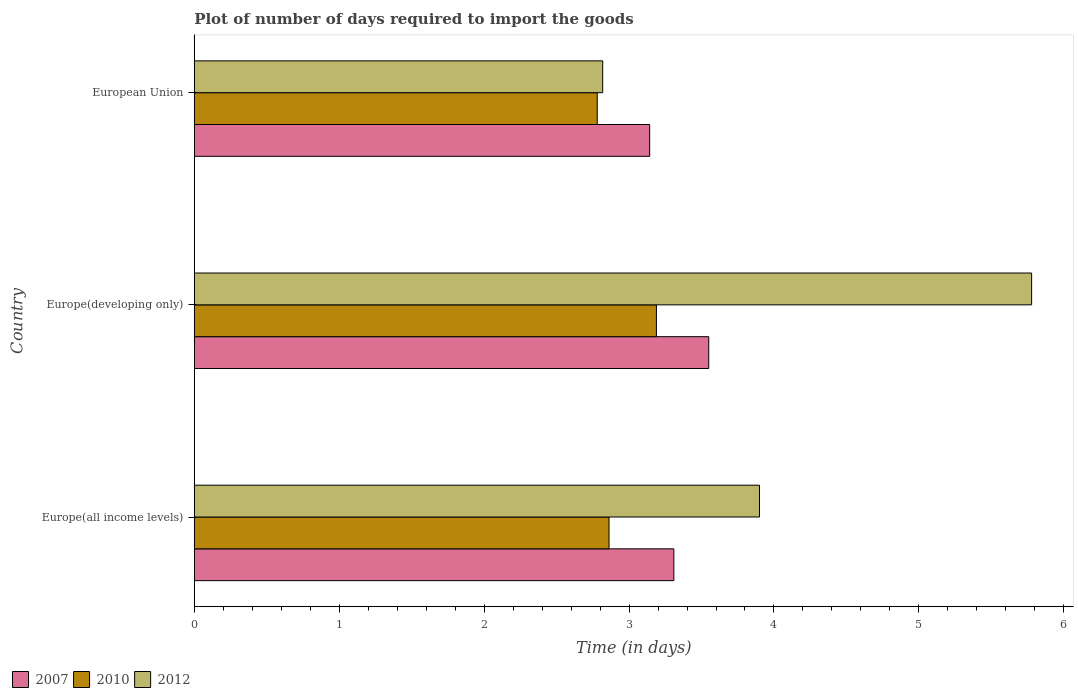How many different coloured bars are there?
Make the answer very short. 3. How many groups of bars are there?
Ensure brevity in your answer.  3. Are the number of bars per tick equal to the number of legend labels?
Your response must be concise. Yes. Are the number of bars on each tick of the Y-axis equal?
Provide a succinct answer. Yes. How many bars are there on the 3rd tick from the bottom?
Provide a short and direct response. 3. What is the time required to import goods in 2010 in European Union?
Keep it short and to the point. 2.78. Across all countries, what is the maximum time required to import goods in 2012?
Give a very brief answer. 5.78. Across all countries, what is the minimum time required to import goods in 2012?
Provide a succinct answer. 2.82. In which country was the time required to import goods in 2007 maximum?
Provide a short and direct response. Europe(developing only). In which country was the time required to import goods in 2007 minimum?
Offer a terse response. European Union. What is the total time required to import goods in 2007 in the graph?
Your response must be concise. 10. What is the difference between the time required to import goods in 2007 in Europe(all income levels) and that in Europe(developing only)?
Your response must be concise. -0.24. What is the difference between the time required to import goods in 2012 in Europe(all income levels) and the time required to import goods in 2007 in Europe(developing only)?
Your answer should be very brief. 0.35. What is the average time required to import goods in 2010 per country?
Your answer should be very brief. 2.94. What is the difference between the time required to import goods in 2010 and time required to import goods in 2007 in European Union?
Make the answer very short. -0.36. In how many countries, is the time required to import goods in 2007 greater than 0.4 days?
Provide a short and direct response. 3. What is the ratio of the time required to import goods in 2012 in Europe(developing only) to that in European Union?
Your response must be concise. 2.05. Is the difference between the time required to import goods in 2010 in Europe(developing only) and European Union greater than the difference between the time required to import goods in 2007 in Europe(developing only) and European Union?
Make the answer very short. Yes. What is the difference between the highest and the second highest time required to import goods in 2007?
Your answer should be very brief. 0.24. What is the difference between the highest and the lowest time required to import goods in 2007?
Keep it short and to the point. 0.41. What does the 1st bar from the top in European Union represents?
Make the answer very short. 2012. How many bars are there?
Ensure brevity in your answer.  9. Are all the bars in the graph horizontal?
Offer a terse response. Yes. Are the values on the major ticks of X-axis written in scientific E-notation?
Make the answer very short. No. Does the graph contain any zero values?
Keep it short and to the point. No. What is the title of the graph?
Give a very brief answer. Plot of number of days required to import the goods. What is the label or title of the X-axis?
Provide a short and direct response. Time (in days). What is the label or title of the Y-axis?
Give a very brief answer. Country. What is the Time (in days) in 2007 in Europe(all income levels)?
Keep it short and to the point. 3.31. What is the Time (in days) in 2010 in Europe(all income levels)?
Offer a very short reply. 2.86. What is the Time (in days) of 2012 in Europe(all income levels)?
Your answer should be very brief. 3.9. What is the Time (in days) in 2007 in Europe(developing only)?
Your answer should be compact. 3.55. What is the Time (in days) of 2010 in Europe(developing only)?
Make the answer very short. 3.19. What is the Time (in days) in 2012 in Europe(developing only)?
Offer a terse response. 5.78. What is the Time (in days) of 2007 in European Union?
Give a very brief answer. 3.14. What is the Time (in days) of 2010 in European Union?
Your response must be concise. 2.78. What is the Time (in days) in 2012 in European Union?
Provide a succinct answer. 2.82. Across all countries, what is the maximum Time (in days) of 2007?
Your response must be concise. 3.55. Across all countries, what is the maximum Time (in days) of 2010?
Your answer should be compact. 3.19. Across all countries, what is the maximum Time (in days) in 2012?
Keep it short and to the point. 5.78. Across all countries, what is the minimum Time (in days) in 2007?
Provide a succinct answer. 3.14. Across all countries, what is the minimum Time (in days) of 2010?
Provide a short and direct response. 2.78. Across all countries, what is the minimum Time (in days) in 2012?
Make the answer very short. 2.82. What is the total Time (in days) in 2007 in the graph?
Provide a succinct answer. 10. What is the total Time (in days) of 2010 in the graph?
Make the answer very short. 8.83. What is the total Time (in days) of 2012 in the graph?
Offer a terse response. 12.5. What is the difference between the Time (in days) in 2007 in Europe(all income levels) and that in Europe(developing only)?
Provide a succinct answer. -0.24. What is the difference between the Time (in days) of 2010 in Europe(all income levels) and that in Europe(developing only)?
Ensure brevity in your answer.  -0.33. What is the difference between the Time (in days) of 2012 in Europe(all income levels) and that in Europe(developing only)?
Give a very brief answer. -1.88. What is the difference between the Time (in days) of 2007 in Europe(all income levels) and that in European Union?
Your answer should be very brief. 0.17. What is the difference between the Time (in days) in 2010 in Europe(all income levels) and that in European Union?
Offer a terse response. 0.08. What is the difference between the Time (in days) in 2012 in Europe(all income levels) and that in European Union?
Provide a short and direct response. 1.08. What is the difference between the Time (in days) of 2007 in Europe(developing only) and that in European Union?
Keep it short and to the point. 0.41. What is the difference between the Time (in days) of 2010 in Europe(developing only) and that in European Union?
Offer a terse response. 0.41. What is the difference between the Time (in days) of 2012 in Europe(developing only) and that in European Union?
Give a very brief answer. 2.96. What is the difference between the Time (in days) in 2007 in Europe(all income levels) and the Time (in days) in 2010 in Europe(developing only)?
Make the answer very short. 0.12. What is the difference between the Time (in days) of 2007 in Europe(all income levels) and the Time (in days) of 2012 in Europe(developing only)?
Give a very brief answer. -2.47. What is the difference between the Time (in days) of 2010 in Europe(all income levels) and the Time (in days) of 2012 in Europe(developing only)?
Ensure brevity in your answer.  -2.92. What is the difference between the Time (in days) of 2007 in Europe(all income levels) and the Time (in days) of 2010 in European Union?
Keep it short and to the point. 0.53. What is the difference between the Time (in days) of 2007 in Europe(all income levels) and the Time (in days) of 2012 in European Union?
Make the answer very short. 0.49. What is the difference between the Time (in days) in 2010 in Europe(all income levels) and the Time (in days) in 2012 in European Union?
Your answer should be very brief. 0.04. What is the difference between the Time (in days) of 2007 in Europe(developing only) and the Time (in days) of 2010 in European Union?
Give a very brief answer. 0.77. What is the difference between the Time (in days) in 2007 in Europe(developing only) and the Time (in days) in 2012 in European Union?
Ensure brevity in your answer.  0.73. What is the difference between the Time (in days) of 2010 in Europe(developing only) and the Time (in days) of 2012 in European Union?
Keep it short and to the point. 0.37. What is the average Time (in days) of 2007 per country?
Your answer should be compact. 3.33. What is the average Time (in days) of 2010 per country?
Provide a succinct answer. 2.94. What is the average Time (in days) in 2012 per country?
Provide a short and direct response. 4.17. What is the difference between the Time (in days) in 2007 and Time (in days) in 2010 in Europe(all income levels)?
Offer a terse response. 0.45. What is the difference between the Time (in days) of 2007 and Time (in days) of 2012 in Europe(all income levels)?
Keep it short and to the point. -0.59. What is the difference between the Time (in days) of 2010 and Time (in days) of 2012 in Europe(all income levels)?
Your answer should be very brief. -1.04. What is the difference between the Time (in days) of 2007 and Time (in days) of 2010 in Europe(developing only)?
Your response must be concise. 0.36. What is the difference between the Time (in days) in 2007 and Time (in days) in 2012 in Europe(developing only)?
Provide a succinct answer. -2.23. What is the difference between the Time (in days) in 2010 and Time (in days) in 2012 in Europe(developing only)?
Offer a terse response. -2.59. What is the difference between the Time (in days) of 2007 and Time (in days) of 2010 in European Union?
Provide a short and direct response. 0.36. What is the difference between the Time (in days) in 2007 and Time (in days) in 2012 in European Union?
Ensure brevity in your answer.  0.32. What is the difference between the Time (in days) of 2010 and Time (in days) of 2012 in European Union?
Your response must be concise. -0.04. What is the ratio of the Time (in days) of 2007 in Europe(all income levels) to that in Europe(developing only)?
Offer a terse response. 0.93. What is the ratio of the Time (in days) of 2010 in Europe(all income levels) to that in Europe(developing only)?
Your answer should be compact. 0.9. What is the ratio of the Time (in days) in 2012 in Europe(all income levels) to that in Europe(developing only)?
Offer a very short reply. 0.68. What is the ratio of the Time (in days) in 2007 in Europe(all income levels) to that in European Union?
Your response must be concise. 1.05. What is the ratio of the Time (in days) in 2010 in Europe(all income levels) to that in European Union?
Your answer should be very brief. 1.03. What is the ratio of the Time (in days) in 2012 in Europe(all income levels) to that in European Union?
Keep it short and to the point. 1.38. What is the ratio of the Time (in days) in 2007 in Europe(developing only) to that in European Union?
Offer a very short reply. 1.13. What is the ratio of the Time (in days) of 2010 in Europe(developing only) to that in European Union?
Offer a very short reply. 1.15. What is the ratio of the Time (in days) in 2012 in Europe(developing only) to that in European Union?
Provide a succinct answer. 2.05. What is the difference between the highest and the second highest Time (in days) in 2007?
Provide a short and direct response. 0.24. What is the difference between the highest and the second highest Time (in days) in 2010?
Your response must be concise. 0.33. What is the difference between the highest and the second highest Time (in days) in 2012?
Your response must be concise. 1.88. What is the difference between the highest and the lowest Time (in days) in 2007?
Your answer should be very brief. 0.41. What is the difference between the highest and the lowest Time (in days) in 2010?
Ensure brevity in your answer.  0.41. What is the difference between the highest and the lowest Time (in days) of 2012?
Provide a succinct answer. 2.96. 